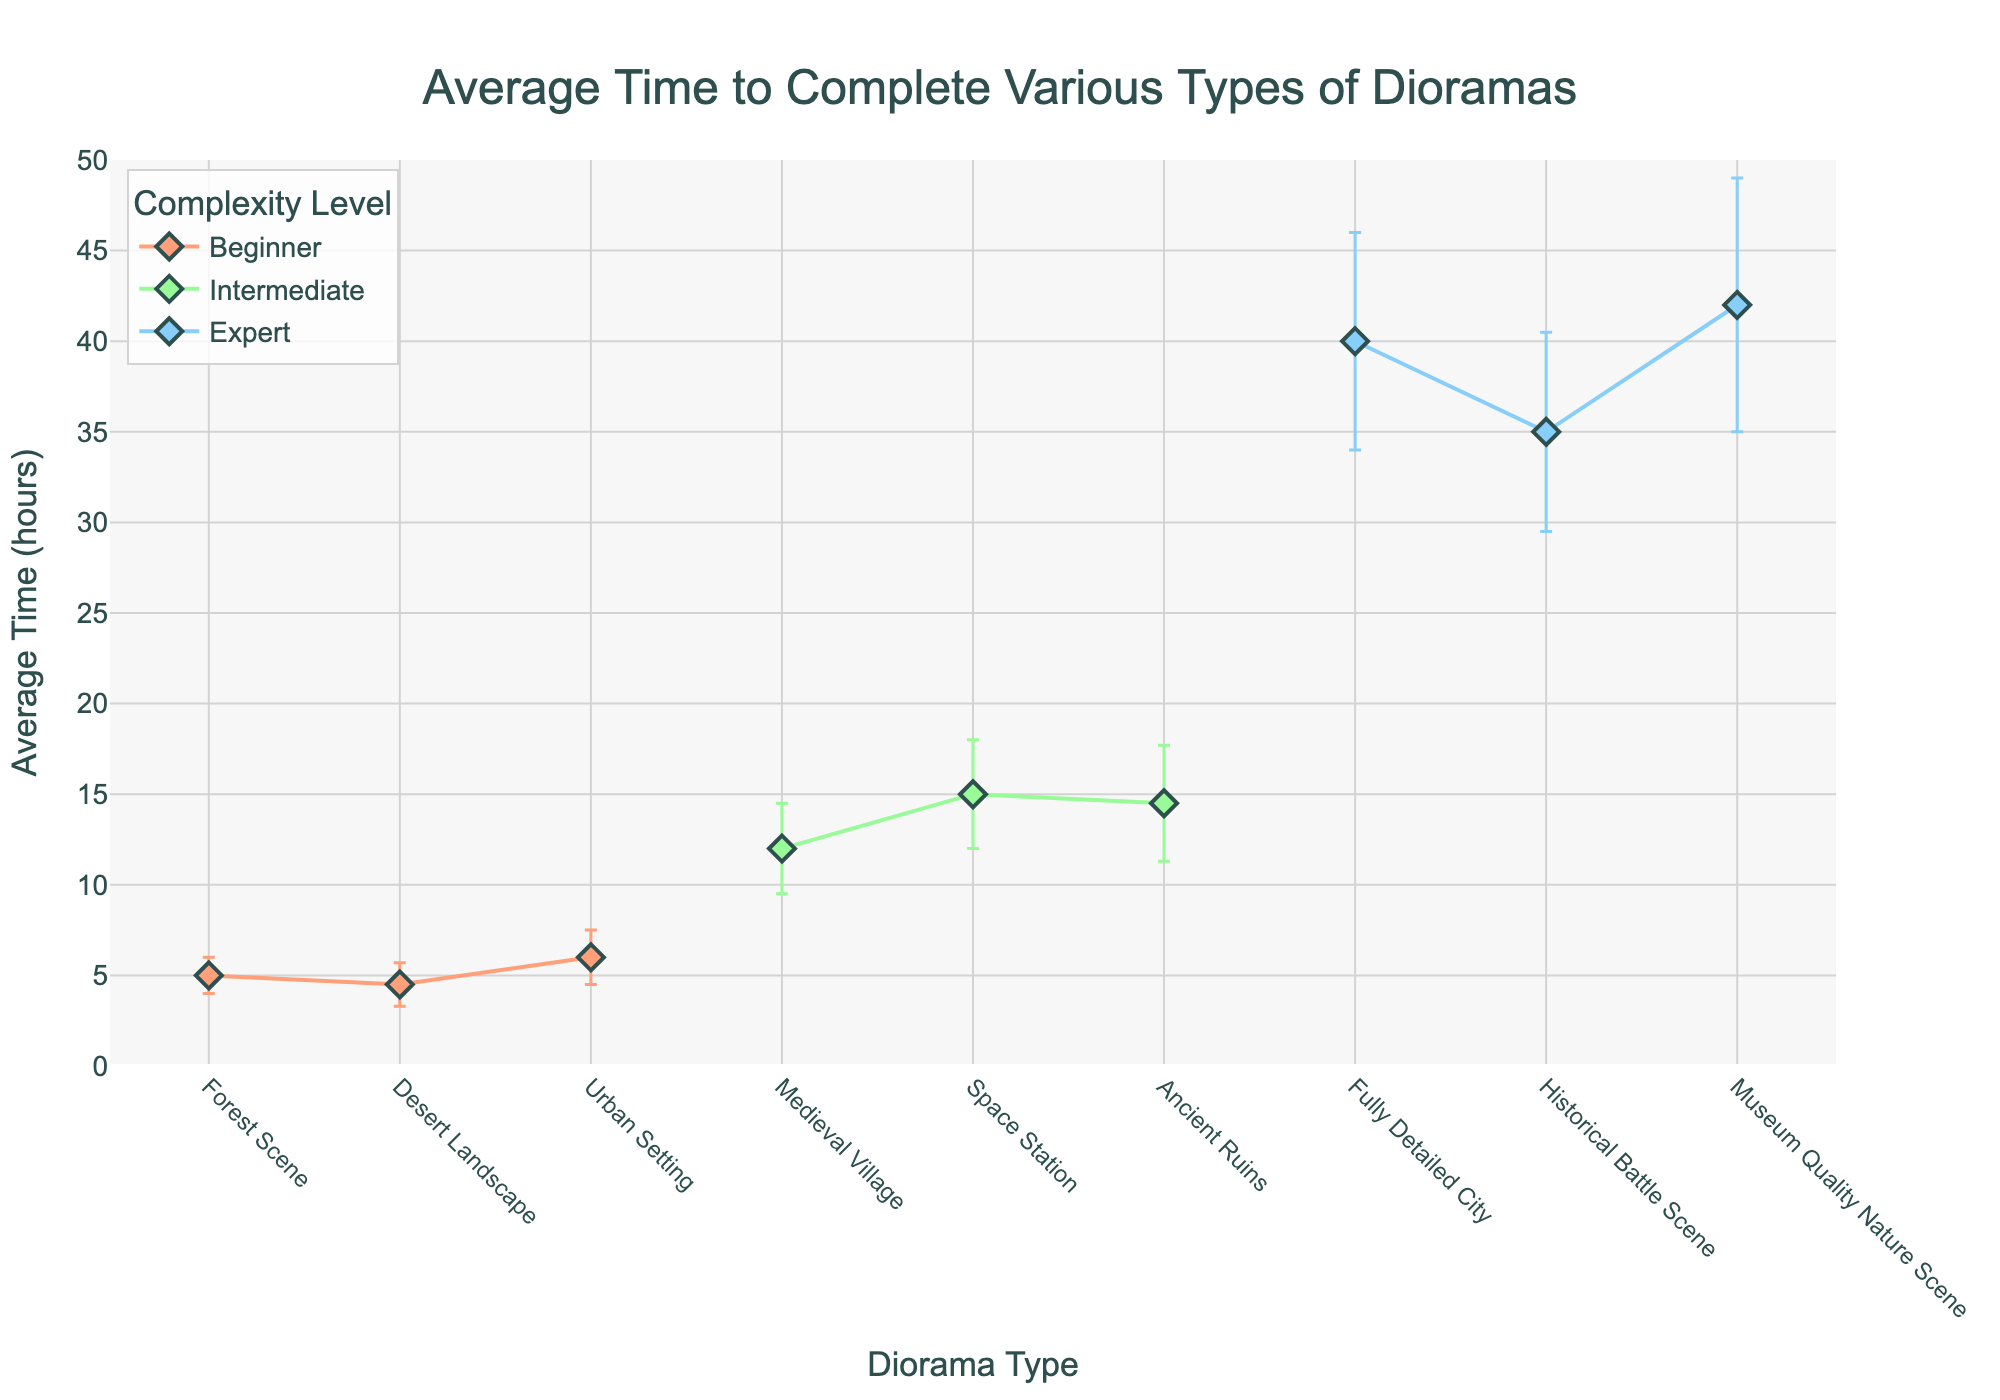what is the title of the figure? The title is usually located at the top-center of the plot. Here, the figure's title reads "Average Time to Complete Various Types of Dioramas".
Answer: Average Time to Complete Various Types of Dioramas Which complexity level has the most diorama types depicted in the figure? To answer this, count the number of diorama types for each complexity level. There are three types each under 'beginner', 'intermediate', and 'expert' complexities.
Answer: All complexities have the same number of types What is the average time to complete the 'Space Station' diorama? Look for the 'Space Station' under the intermediate complexity. The plot shows its average time to complete as 15 hours.
Answer: 15 hours What is the total average time to complete all beginner-level dioramas? Sum the average times for 'Forest Scene' (5), 'Desert Landscape' (4.5), and 'Urban Setting' (6). So, 5 + 4.5 + 6 = 15.5 hours.
Answer: 15.5 hours Which diorama type has the highest average completion time, and what is it? Examine the y-values for all diorama types. The 'Museum Quality Nature Scene' has the highest y-value at 42 hours.
Answer: Museum Quality Nature Scene, 42 hours How does the average time to complete 'Desert Landscape' compare to 'Ancient Ruins'? Check the y-values for both. The 'Desert Landscape' (4.5 hours) requires significantly less time than 'Ancient Ruins' (14.5 hours).
Answer: Desert Landscape is 10 hours less Among the expert level dioramas, which one has the largest error bar? Look at the length of the error bars for 'Fully Detailed City', 'Historical Battle Scene', and 'Museum Quality Nature Scene'. 'Museum Quality Nature Scene' has the largest error bar (7 hours).
Answer: Museum Quality Nature Scene What is the average time to complete all intermediate-level dioramas? Sum the average times: 'Medieval Village' (12), 'Space Station' (15), 'Ancient Ruins' (14.5). The total is 12 + 15 + 14.5 = 41.5 hours. Divide by 3 for average: 41.5 / 3 ≈ 13.83 hours.
Answer: Approx. 13.83 hours Between beginner and expert complexity levels as a whole, which has the smaller average time to complete? Sum the average times for each complexity level: Beginner (5 + 4.5 + 6 = 15.5 hours), Expert (40 + 35 + 42 = 117 hours). Comparing, beginners take much less time.
Answer: Beginner complexity Is the average time to complete the 'Medieval Village' diorama more or less than double the time for 'Forest Scene'? The average time for 'Medieval Village' is 12 hours, and for 'Forest Scene' it is 5 hours. Doubling 5 gives 10, which is less than 12.
Answer: More 